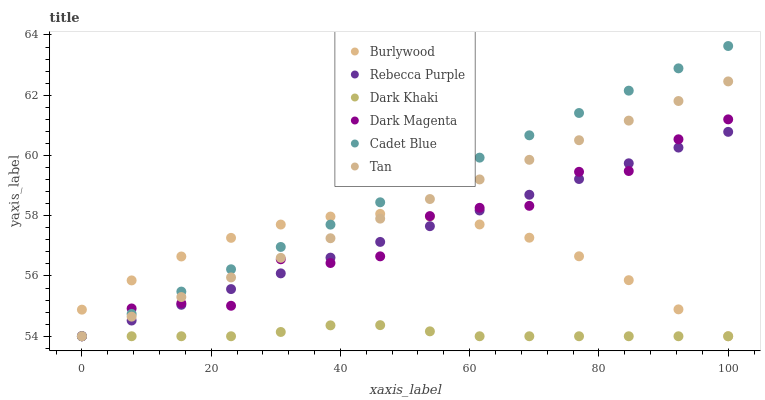Does Dark Khaki have the minimum area under the curve?
Answer yes or no. Yes. Does Cadet Blue have the maximum area under the curve?
Answer yes or no. Yes. Does Dark Magenta have the minimum area under the curve?
Answer yes or no. No. Does Dark Magenta have the maximum area under the curve?
Answer yes or no. No. Is Rebecca Purple the smoothest?
Answer yes or no. Yes. Is Dark Magenta the roughest?
Answer yes or no. Yes. Is Burlywood the smoothest?
Answer yes or no. No. Is Burlywood the roughest?
Answer yes or no. No. Does Cadet Blue have the lowest value?
Answer yes or no. Yes. Does Cadet Blue have the highest value?
Answer yes or no. Yes. Does Dark Magenta have the highest value?
Answer yes or no. No. Does Burlywood intersect Dark Magenta?
Answer yes or no. Yes. Is Burlywood less than Dark Magenta?
Answer yes or no. No. Is Burlywood greater than Dark Magenta?
Answer yes or no. No. 